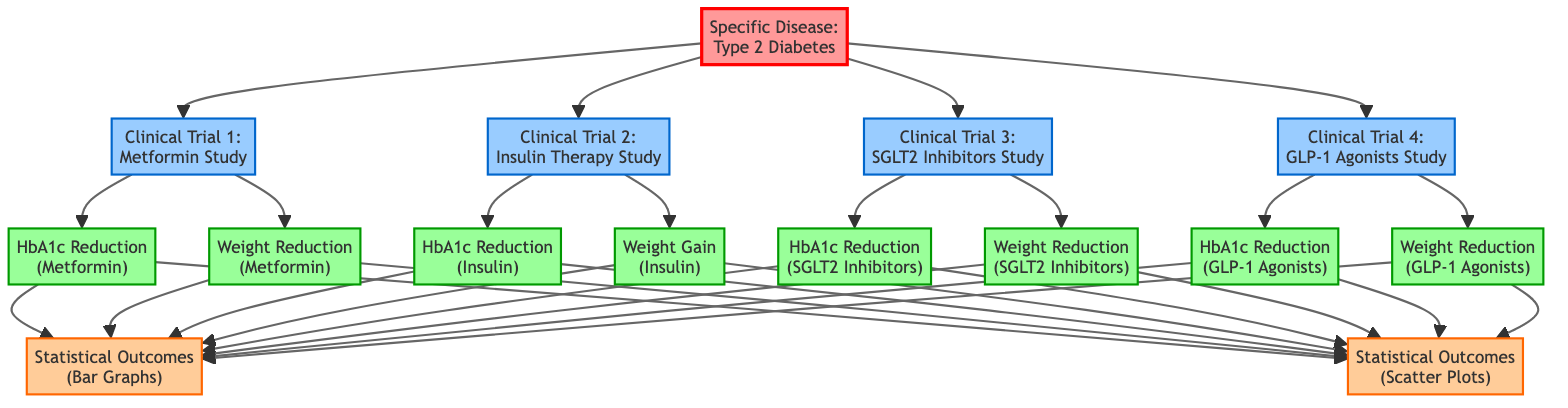What is the specific disease illustrated in the diagram? The diagram identifies the specific disease as Type 2 Diabetes, as indicated in the disease node.
Answer: Type 2 Diabetes How many clinical trials are presented in the diagram? The diagram includes four clinical trials, each represented as separate trial nodes linked to the disease node.
Answer: 4 Which clinical trial is associated with Metformin? The trial associated with Metformin is labeled Clinical Trial 1, specifically the Metformin Study, as depicted in the corresponding node.
Answer: Clinical Trial 1 What is the statistical outcome related to SGLT2 Inhibitors? The diagram displays two statistical outcomes related to SGLT2 Inhibitors: one for HbA1c Reduction and another for Weight Reduction, indicated under outcomes from Clinical Trial 3.
Answer: HbA1c Reduction and Weight Reduction Which treatment showed weight gain as a statistical outcome? The statistical outcome showing weight gain comes from the Insulin Therapy Study, specifically indicated under Clinical Trial 2 in the diagram.
Answer: Insulin Therapy Study Which treatment has the highest emphasis on weight reduction outcomes? The treatments with the highest emphasis on weight reduction outcomes are SGLT2 Inhibitors and GLP-1 Agonists, as both are associated with weight reduction outcomes in two clinical trials.
Answer: SGLT2 Inhibitors and GLP-1 Agonists How do HbA1c reductions from Metformin and GLP-1 Agonists compare? To answer this, we observe that both treatments report HbA1c reduction outcomes, allowing a comparison between their effectiveness based on their respective nodes for statistical outcomes.
Answer: Comparison requires data, not shown Which outcome type is represented by both bar graphs and scatter plots? The outcome type represented by both statistical visuals (bar graphs and scatter plots) is the overall statistical outcomes node, indicated to branch from all the individual treatment outcomes.
Answer: Statistical Outcomes 